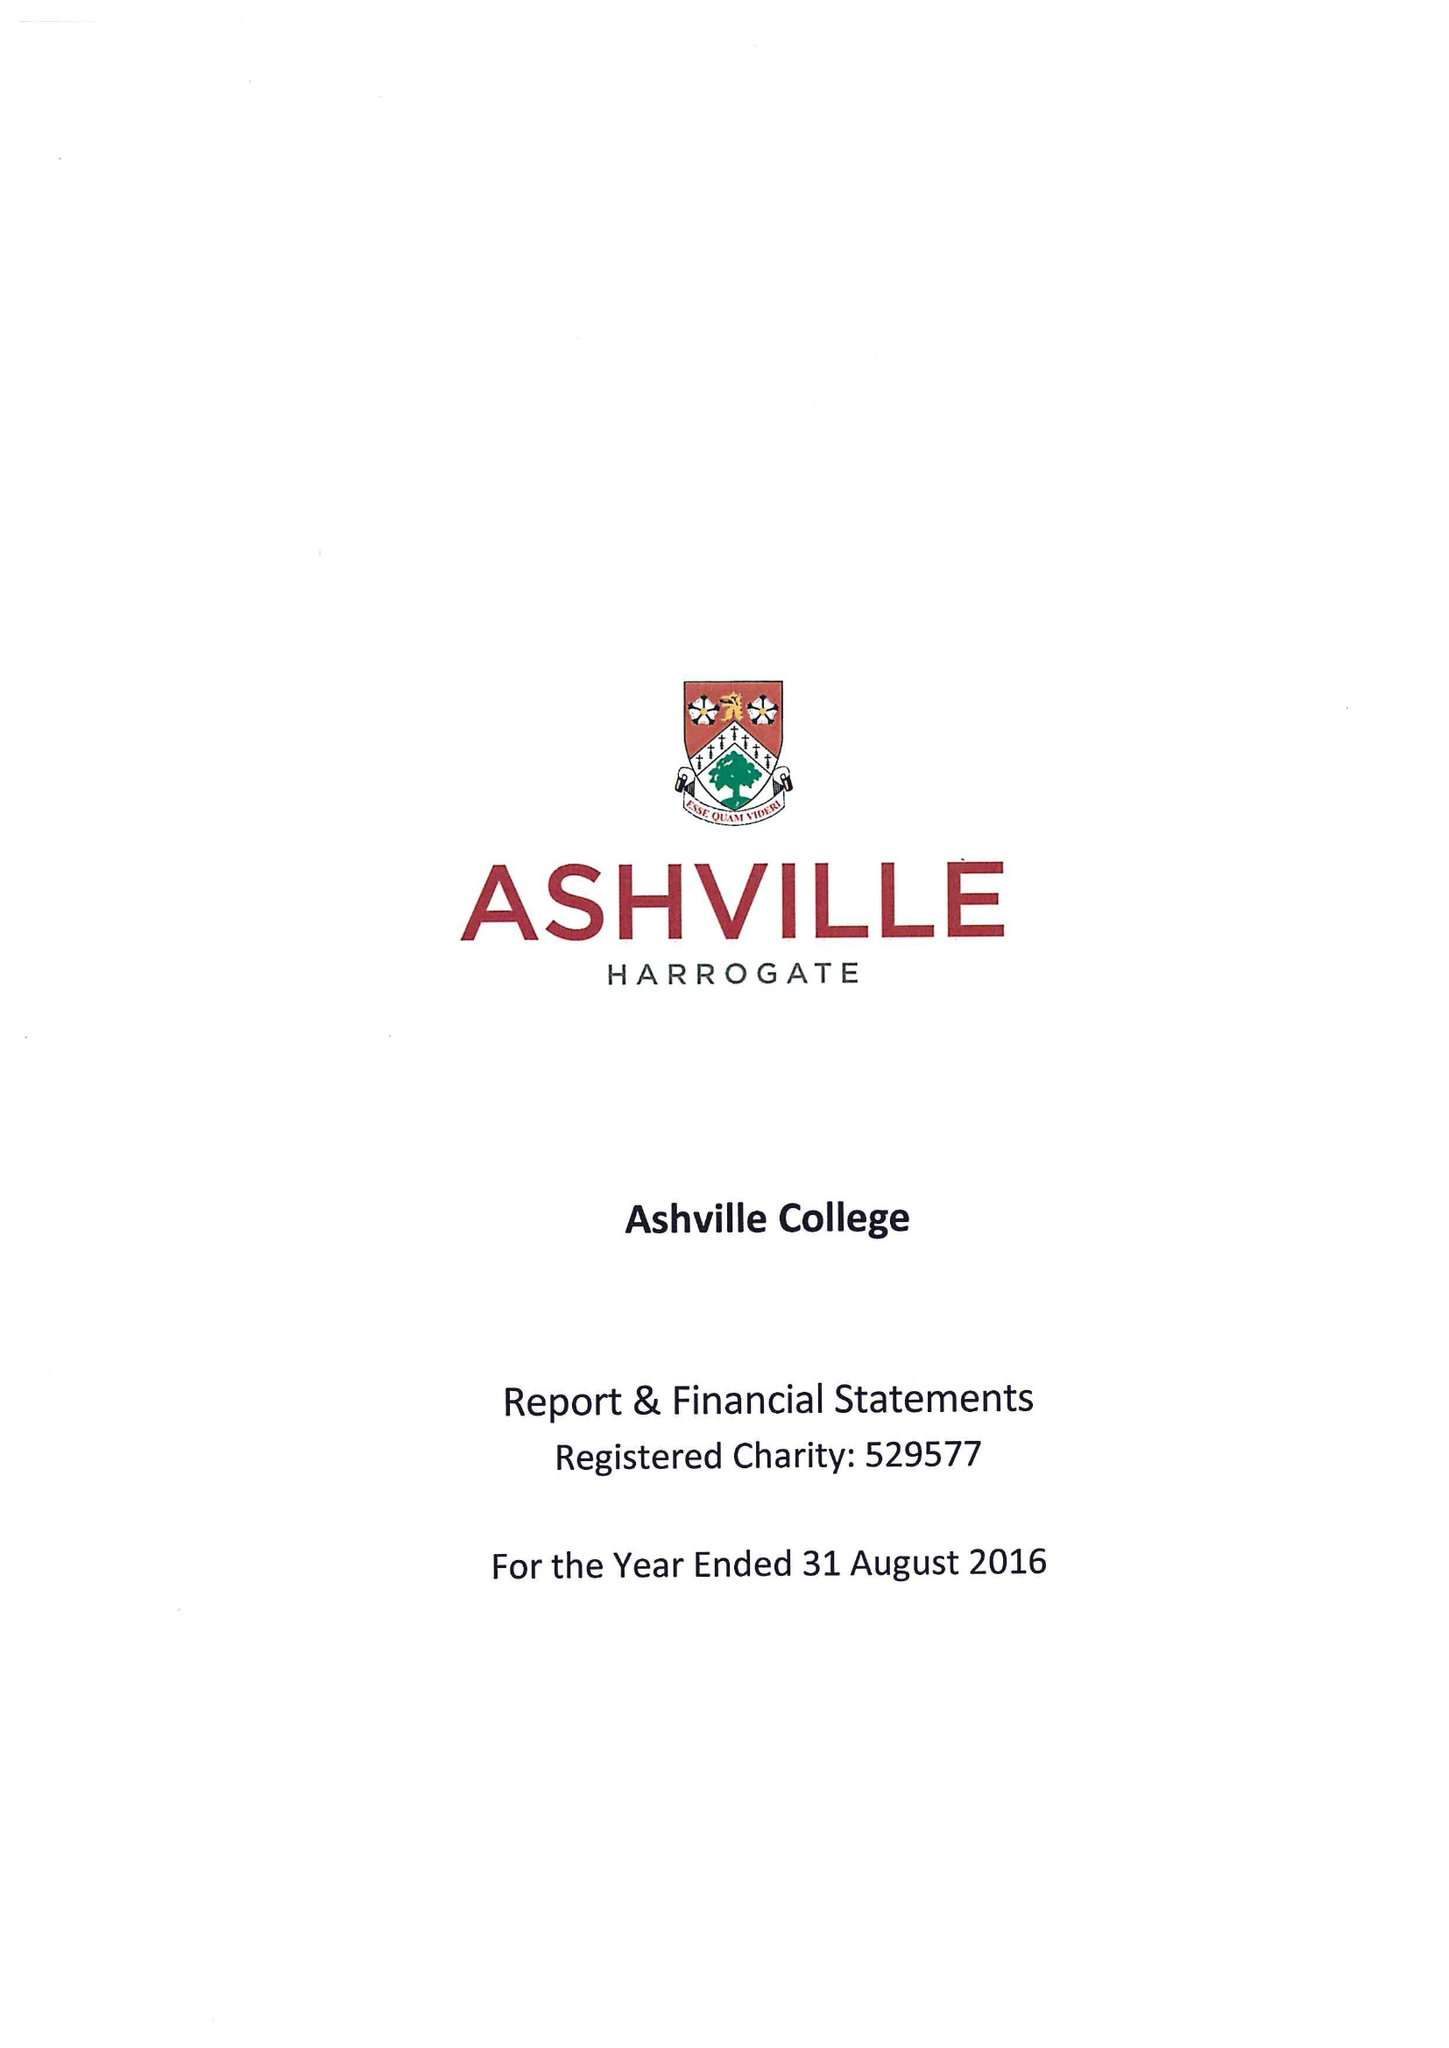What is the value for the address__postcode?
Answer the question using a single word or phrase. HG2 9JP 